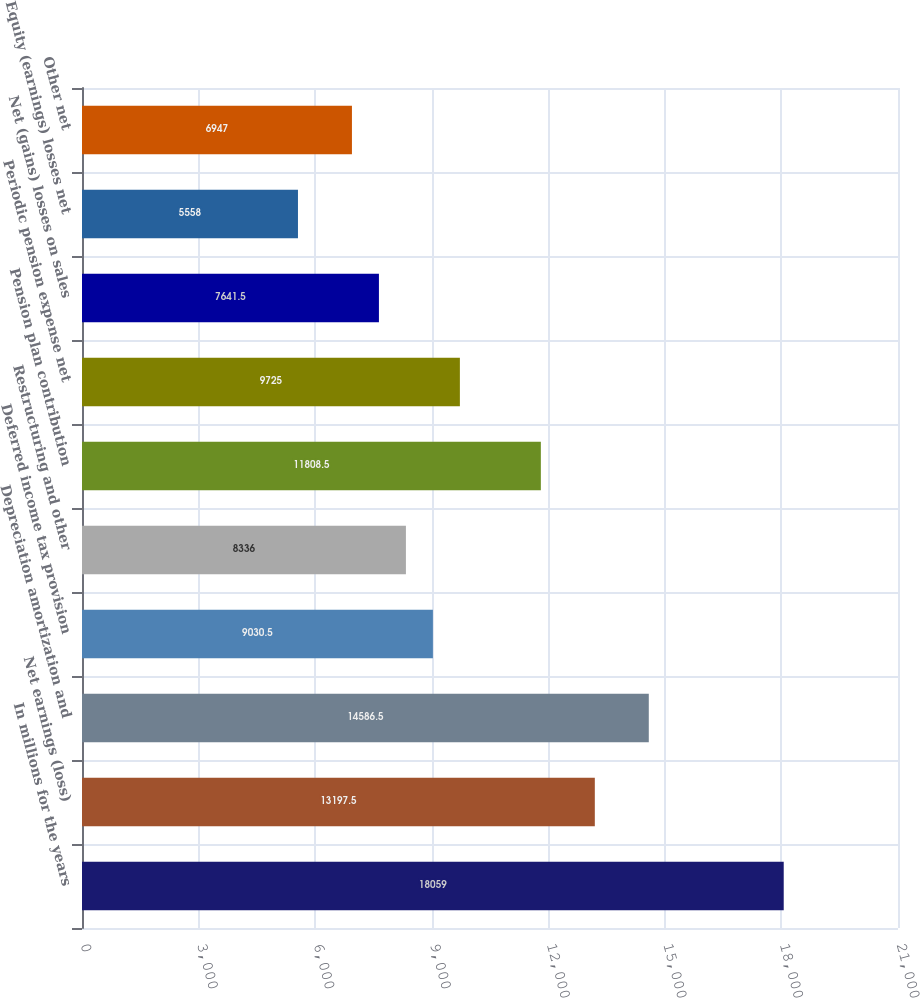<chart> <loc_0><loc_0><loc_500><loc_500><bar_chart><fcel>In millions for the years<fcel>Net earnings (loss)<fcel>Depreciation amortization and<fcel>Deferred income tax provision<fcel>Restructuring and other<fcel>Pension plan contribution<fcel>Periodic pension expense net<fcel>Net (gains) losses on sales<fcel>Equity (earnings) losses net<fcel>Other net<nl><fcel>18059<fcel>13197.5<fcel>14586.5<fcel>9030.5<fcel>8336<fcel>11808.5<fcel>9725<fcel>7641.5<fcel>5558<fcel>6947<nl></chart> 